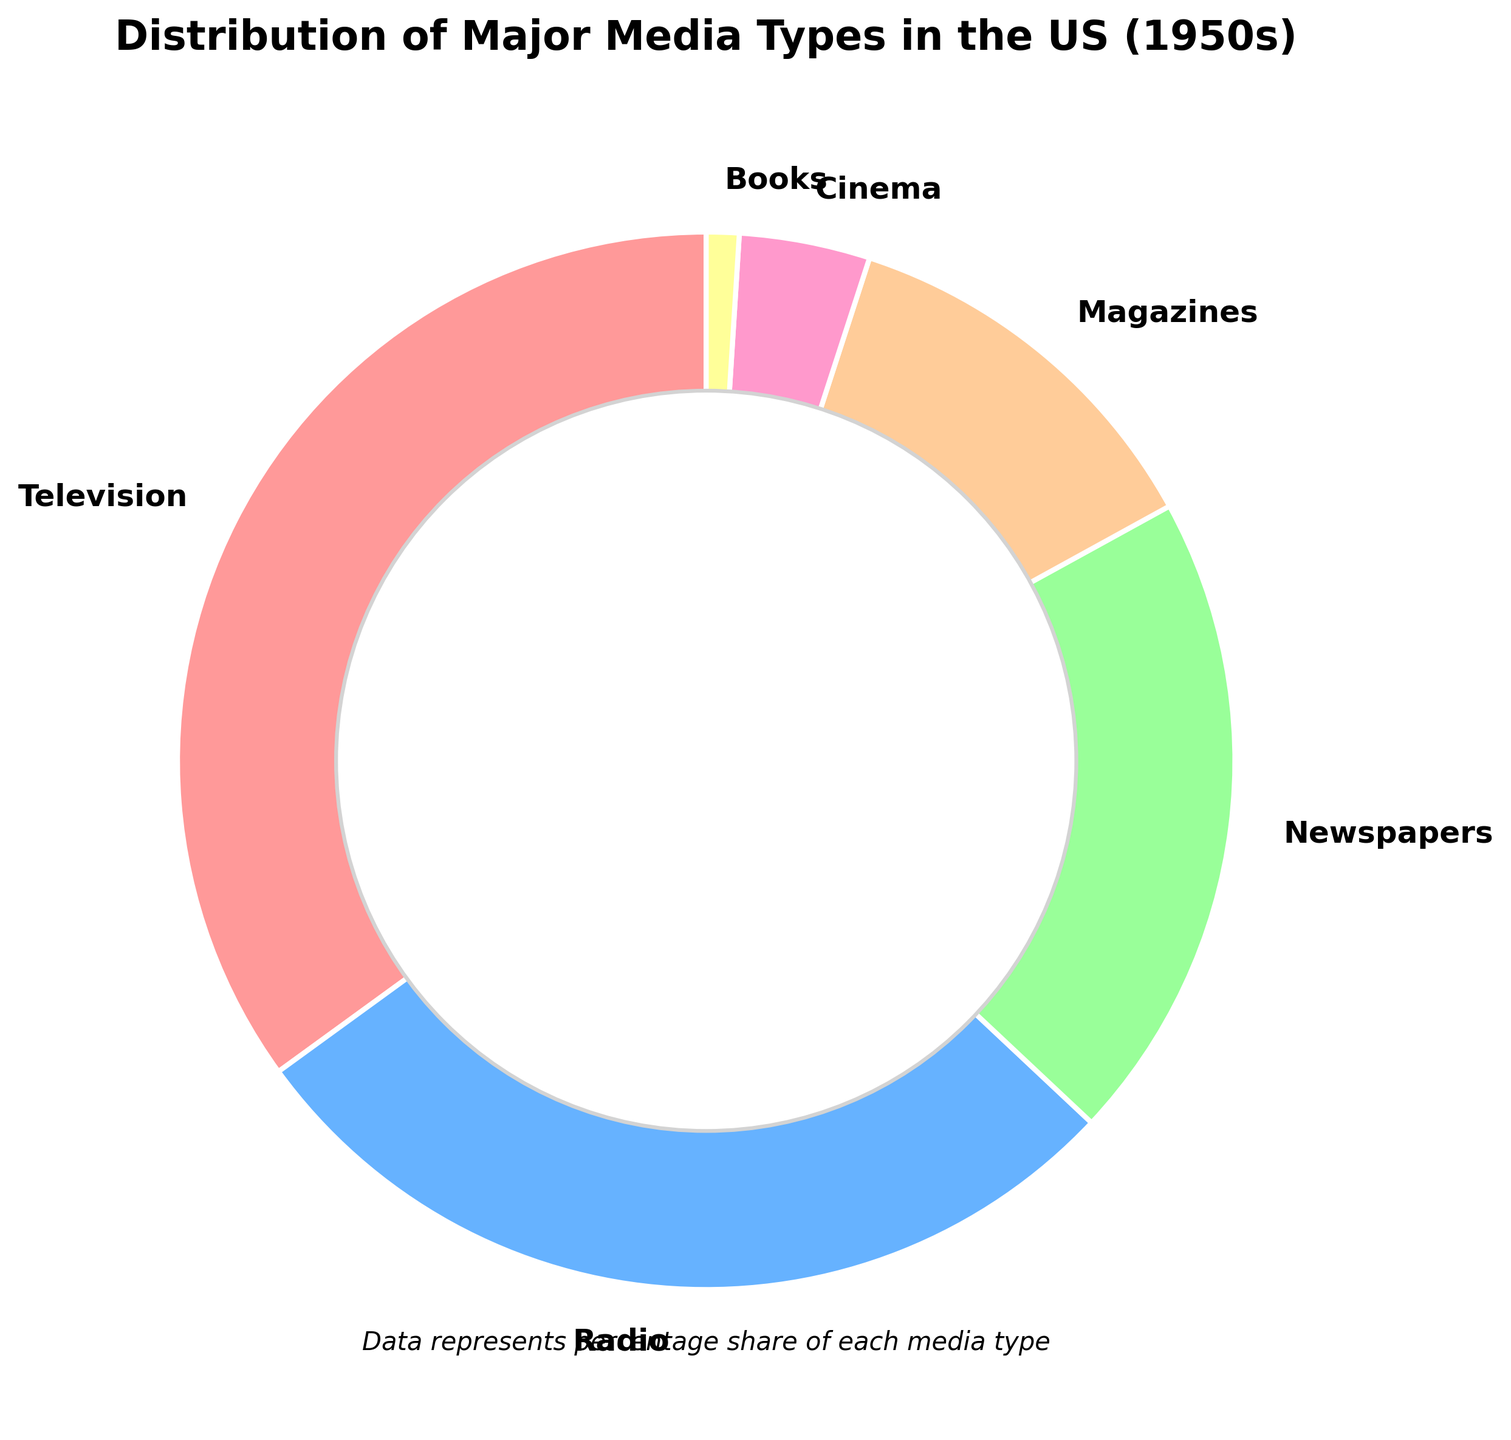Which media type had the highest percentage in the 1950s? The pie chart shows different segments for each media type, and the largest segment represents the highest percentage. Television occupies the largest segment with 35%.
Answer: Television Which two media types combined had a percentage close to 50%? To find the media types that together make up around 50%, we examine the individual percentages and sum different combinations until we find a suitable pair. Adding Television (35%) and Magazines (12%) results in 47%, which isn't close enough. But adding Television (35%) and Radio (28%) results in 63%. Therefore, the closest combination is Radio (28%) and Newspapers (20%), summing to 48%.
Answer: Radio and Newspapers How much larger is the percentage of television compared to books? To determine how much larger one percentage is compared to another, we subtract the smaller percentage from the larger one. The percentage for Television is 35%, and for Books, it is 1%. Thus, 35% - 1% = 34%.
Answer: 34% What is the smallest media type by percentage, and what is its color? The smallest segment in the pie chart represents the smallest media type by percentage. This segment represents Books and is colored yellow.
Answer: Books, yellow What percentage of the media types combined made up less than radio? To find the percentage of media types combined that is less than Radio, we add the percentages of Cinema (4%) and Books (1%), resulting in 5%. Adding Newspapers (20%) or Magazines (12%) would exceed the Radio percentage (28%).
Answer: Cinema and Books Which media type has the third largest share, and what is its percentage? Observing the segments from largest to smallest shows that the third-largest segment represents Newspapers, which has a 20% share.
Answer: Newspapers, 20% If you combine the percentages of magazines and cinema, what is the result? Adding the percentages of Magazines (12%) and Cinema (4%) results in 12% + 4% = 16%.
Answer: 16% What is the difference in percentage between newspapers and radio? To find the difference, subtract the smaller percentage from the larger one. The percentage for Radio is 28%, and for Newspapers, it is 20%. Thus, 28% - 20% = 8%.
Answer: 8% Which media types have an almost equal share, and what are their respective percentages? The pie chart shows the sizes of segments, and by examining them, we find that Radio has 28% and Newspapers have 20%, which are not close enough. Magazines have 12%, and combining smaller segments doesn't offer equal share results. There isn't an equal share, but Cinema (4%) and Books (1%) are close. However, this isn't strictly equal, just relatively small compared to others.
Answer: no almost equal shares What is the combined percentage of TV, Radio, and Cinemas? Adding the percentages of Television (35%), Radio (28%), and Cinema (4%) results in 35% + 28% + 4% = 67%.
Answer: 67% 